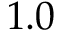<formula> <loc_0><loc_0><loc_500><loc_500>1 . 0</formula> 